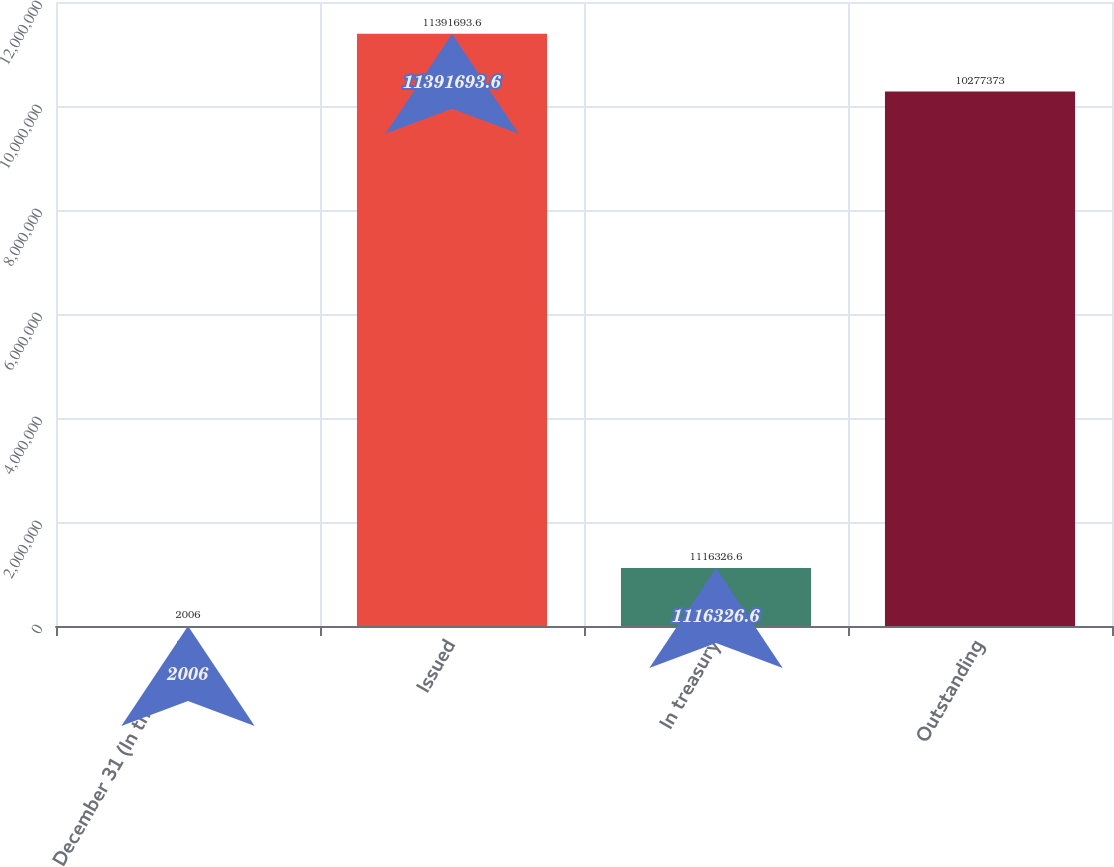Convert chart. <chart><loc_0><loc_0><loc_500><loc_500><bar_chart><fcel>December 31 (In thousands)<fcel>Issued<fcel>In treasury<fcel>Outstanding<nl><fcel>2006<fcel>1.13917e+07<fcel>1.11633e+06<fcel>1.02774e+07<nl></chart> 